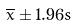Convert formula to latex. <formula><loc_0><loc_0><loc_500><loc_500>\overline { x } \pm 1 . 9 6 s</formula> 